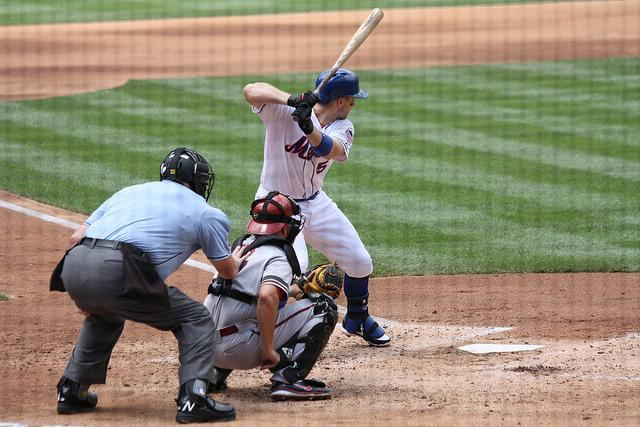What number is the batter? five 